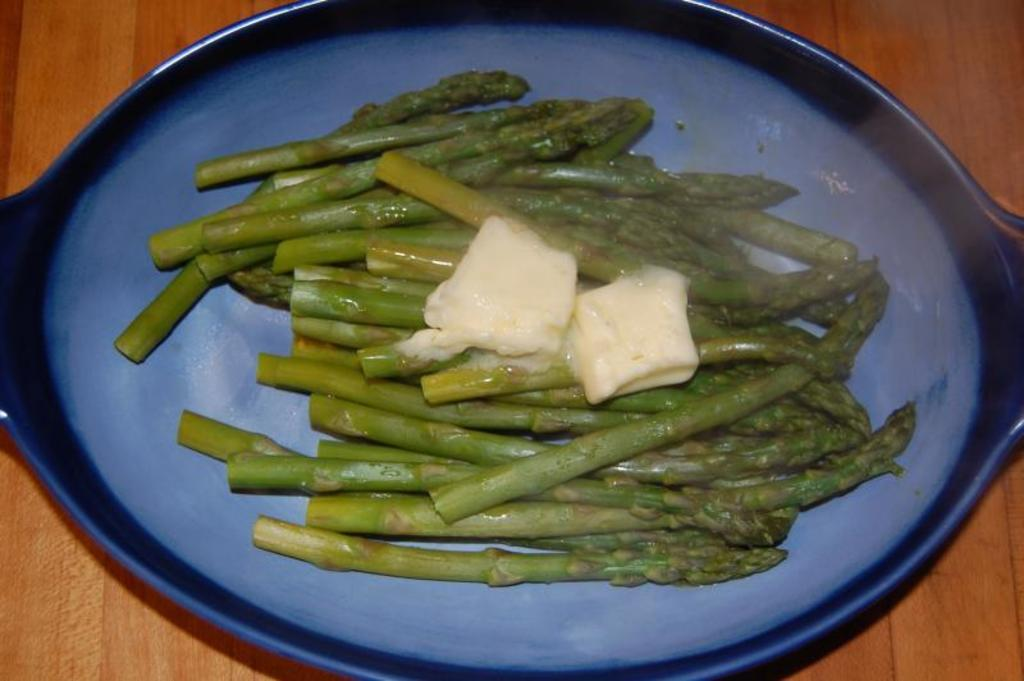What is present in the image that can hold items? There is a bowl in the image. What is inside the bowl? There is food in the bowl. What type of cord is hanging from the bowl in the image? There is no cord present in the image; it only features a bowl with food inside. 